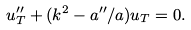<formula> <loc_0><loc_0><loc_500><loc_500>u _ { T } ^ { \prime \prime } + ( k ^ { 2 } - a ^ { \prime \prime } / a ) u _ { T } = 0 .</formula> 